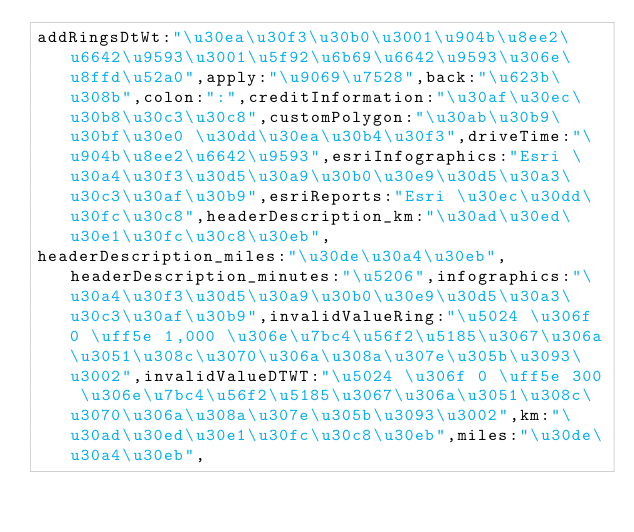<code> <loc_0><loc_0><loc_500><loc_500><_JavaScript_>addRingsDtWt:"\u30ea\u30f3\u30b0\u3001\u904b\u8ee2\u6642\u9593\u3001\u5f92\u6b69\u6642\u9593\u306e\u8ffd\u52a0",apply:"\u9069\u7528",back:"\u623b\u308b",colon:":",creditInformation:"\u30af\u30ec\u30b8\u30c3\u30c8",customPolygon:"\u30ab\u30b9\u30bf\u30e0 \u30dd\u30ea\u30b4\u30f3",driveTime:"\u904b\u8ee2\u6642\u9593",esriInfographics:"Esri \u30a4\u30f3\u30d5\u30a9\u30b0\u30e9\u30d5\u30a3\u30c3\u30af\u30b9",esriReports:"Esri \u30ec\u30dd\u30fc\u30c8",headerDescription_km:"\u30ad\u30ed\u30e1\u30fc\u30c8\u30eb",
headerDescription_miles:"\u30de\u30a4\u30eb",headerDescription_minutes:"\u5206",infographics:"\u30a4\u30f3\u30d5\u30a9\u30b0\u30e9\u30d5\u30a3\u30c3\u30af\u30b9",invalidValueRing:"\u5024 \u306f 0 \uff5e 1,000 \u306e\u7bc4\u56f2\u5185\u3067\u306a\u3051\u308c\u3070\u306a\u308a\u307e\u305b\u3093\u3002",invalidValueDTWT:"\u5024 \u306f 0 \uff5e 300 \u306e\u7bc4\u56f2\u5185\u3067\u306a\u3051\u308c\u3070\u306a\u308a\u307e\u305b\u3093\u3002",km:"\u30ad\u30ed\u30e1\u30fc\u30c8\u30eb",miles:"\u30de\u30a4\u30eb",</code> 